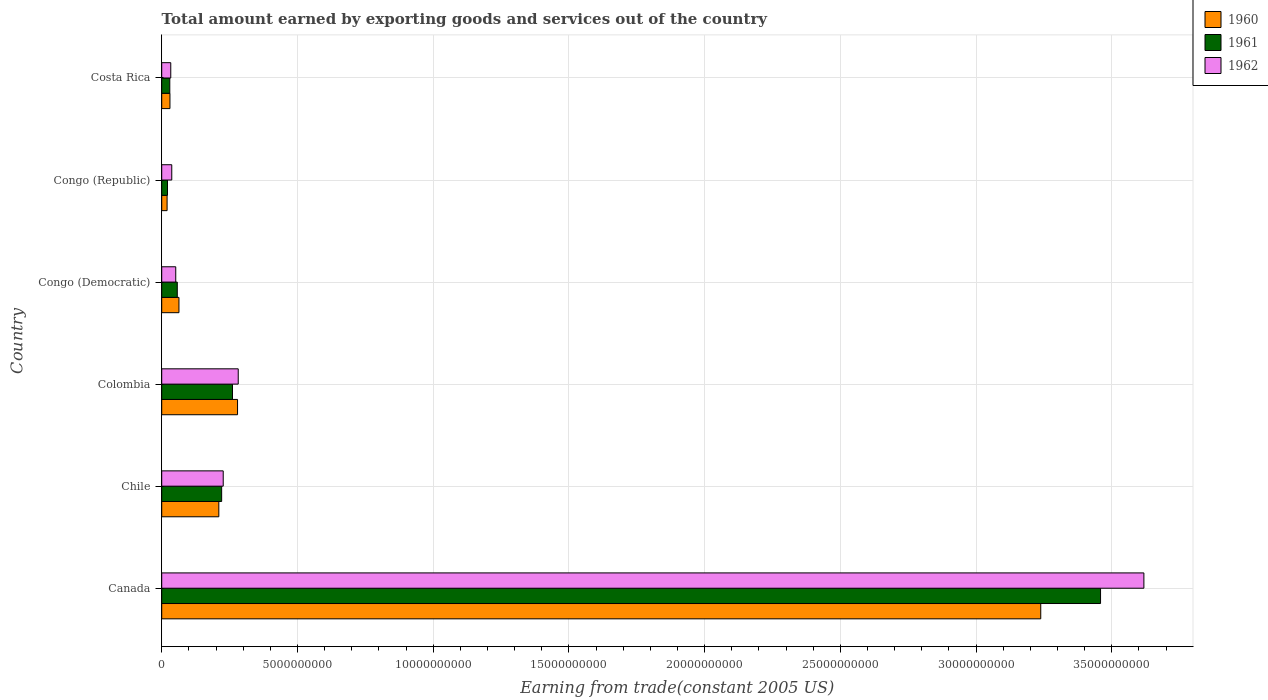How many groups of bars are there?
Make the answer very short. 6. How many bars are there on the 4th tick from the top?
Your answer should be very brief. 3. How many bars are there on the 6th tick from the bottom?
Keep it short and to the point. 3. In how many cases, is the number of bars for a given country not equal to the number of legend labels?
Your answer should be very brief. 0. What is the total amount earned by exporting goods and services in 1960 in Chile?
Give a very brief answer. 2.10e+09. Across all countries, what is the maximum total amount earned by exporting goods and services in 1962?
Make the answer very short. 3.62e+1. Across all countries, what is the minimum total amount earned by exporting goods and services in 1960?
Provide a short and direct response. 1.98e+08. In which country was the total amount earned by exporting goods and services in 1961 minimum?
Provide a succinct answer. Congo (Republic). What is the total total amount earned by exporting goods and services in 1961 in the graph?
Make the answer very short. 4.05e+1. What is the difference between the total amount earned by exporting goods and services in 1960 in Canada and that in Chile?
Provide a short and direct response. 3.03e+1. What is the difference between the total amount earned by exporting goods and services in 1960 in Canada and the total amount earned by exporting goods and services in 1962 in Costa Rica?
Provide a short and direct response. 3.21e+1. What is the average total amount earned by exporting goods and services in 1962 per country?
Give a very brief answer. 7.08e+09. What is the difference between the total amount earned by exporting goods and services in 1960 and total amount earned by exporting goods and services in 1962 in Costa Rica?
Your answer should be very brief. -3.00e+07. In how many countries, is the total amount earned by exporting goods and services in 1960 greater than 35000000000 US$?
Offer a terse response. 0. What is the ratio of the total amount earned by exporting goods and services in 1960 in Colombia to that in Costa Rica?
Offer a very short reply. 9.21. Is the difference between the total amount earned by exporting goods and services in 1960 in Chile and Congo (Republic) greater than the difference between the total amount earned by exporting goods and services in 1962 in Chile and Congo (Republic)?
Your answer should be very brief. Yes. What is the difference between the highest and the second highest total amount earned by exporting goods and services in 1960?
Keep it short and to the point. 2.96e+1. What is the difference between the highest and the lowest total amount earned by exporting goods and services in 1960?
Make the answer very short. 3.22e+1. What does the 3rd bar from the bottom in Costa Rica represents?
Provide a succinct answer. 1962. How many bars are there?
Provide a succinct answer. 18. What is the difference between two consecutive major ticks on the X-axis?
Make the answer very short. 5.00e+09. Are the values on the major ticks of X-axis written in scientific E-notation?
Give a very brief answer. No. Does the graph contain any zero values?
Your answer should be compact. No. How many legend labels are there?
Your answer should be very brief. 3. How are the legend labels stacked?
Your answer should be very brief. Vertical. What is the title of the graph?
Offer a terse response. Total amount earned by exporting goods and services out of the country. What is the label or title of the X-axis?
Give a very brief answer. Earning from trade(constant 2005 US). What is the Earning from trade(constant 2005 US) in 1960 in Canada?
Offer a terse response. 3.24e+1. What is the Earning from trade(constant 2005 US) in 1961 in Canada?
Keep it short and to the point. 3.46e+1. What is the Earning from trade(constant 2005 US) of 1962 in Canada?
Provide a short and direct response. 3.62e+1. What is the Earning from trade(constant 2005 US) of 1960 in Chile?
Make the answer very short. 2.10e+09. What is the Earning from trade(constant 2005 US) of 1961 in Chile?
Offer a very short reply. 2.21e+09. What is the Earning from trade(constant 2005 US) of 1962 in Chile?
Ensure brevity in your answer.  2.27e+09. What is the Earning from trade(constant 2005 US) of 1960 in Colombia?
Offer a terse response. 2.79e+09. What is the Earning from trade(constant 2005 US) of 1961 in Colombia?
Make the answer very short. 2.61e+09. What is the Earning from trade(constant 2005 US) of 1962 in Colombia?
Your answer should be compact. 2.82e+09. What is the Earning from trade(constant 2005 US) in 1960 in Congo (Democratic)?
Your answer should be compact. 6.35e+08. What is the Earning from trade(constant 2005 US) in 1961 in Congo (Democratic)?
Give a very brief answer. 5.73e+08. What is the Earning from trade(constant 2005 US) in 1962 in Congo (Democratic)?
Your answer should be very brief. 5.17e+08. What is the Earning from trade(constant 2005 US) in 1960 in Congo (Republic)?
Keep it short and to the point. 1.98e+08. What is the Earning from trade(constant 2005 US) of 1961 in Congo (Republic)?
Make the answer very short. 2.13e+08. What is the Earning from trade(constant 2005 US) of 1962 in Congo (Republic)?
Offer a very short reply. 3.70e+08. What is the Earning from trade(constant 2005 US) in 1960 in Costa Rica?
Give a very brief answer. 3.03e+08. What is the Earning from trade(constant 2005 US) in 1961 in Costa Rica?
Offer a terse response. 2.98e+08. What is the Earning from trade(constant 2005 US) in 1962 in Costa Rica?
Provide a succinct answer. 3.33e+08. Across all countries, what is the maximum Earning from trade(constant 2005 US) in 1960?
Give a very brief answer. 3.24e+1. Across all countries, what is the maximum Earning from trade(constant 2005 US) of 1961?
Offer a terse response. 3.46e+1. Across all countries, what is the maximum Earning from trade(constant 2005 US) of 1962?
Ensure brevity in your answer.  3.62e+1. Across all countries, what is the minimum Earning from trade(constant 2005 US) of 1960?
Offer a very short reply. 1.98e+08. Across all countries, what is the minimum Earning from trade(constant 2005 US) in 1961?
Your answer should be very brief. 2.13e+08. Across all countries, what is the minimum Earning from trade(constant 2005 US) of 1962?
Offer a very short reply. 3.33e+08. What is the total Earning from trade(constant 2005 US) of 1960 in the graph?
Ensure brevity in your answer.  3.84e+1. What is the total Earning from trade(constant 2005 US) of 1961 in the graph?
Ensure brevity in your answer.  4.05e+1. What is the total Earning from trade(constant 2005 US) in 1962 in the graph?
Make the answer very short. 4.25e+1. What is the difference between the Earning from trade(constant 2005 US) of 1960 in Canada and that in Chile?
Offer a terse response. 3.03e+1. What is the difference between the Earning from trade(constant 2005 US) in 1961 in Canada and that in Chile?
Provide a short and direct response. 3.24e+1. What is the difference between the Earning from trade(constant 2005 US) of 1962 in Canada and that in Chile?
Your response must be concise. 3.39e+1. What is the difference between the Earning from trade(constant 2005 US) in 1960 in Canada and that in Colombia?
Your answer should be very brief. 2.96e+1. What is the difference between the Earning from trade(constant 2005 US) of 1961 in Canada and that in Colombia?
Provide a short and direct response. 3.20e+1. What is the difference between the Earning from trade(constant 2005 US) of 1962 in Canada and that in Colombia?
Your answer should be very brief. 3.34e+1. What is the difference between the Earning from trade(constant 2005 US) of 1960 in Canada and that in Congo (Democratic)?
Your answer should be compact. 3.17e+1. What is the difference between the Earning from trade(constant 2005 US) in 1961 in Canada and that in Congo (Democratic)?
Provide a succinct answer. 3.40e+1. What is the difference between the Earning from trade(constant 2005 US) in 1962 in Canada and that in Congo (Democratic)?
Your response must be concise. 3.57e+1. What is the difference between the Earning from trade(constant 2005 US) of 1960 in Canada and that in Congo (Republic)?
Provide a succinct answer. 3.22e+1. What is the difference between the Earning from trade(constant 2005 US) in 1961 in Canada and that in Congo (Republic)?
Keep it short and to the point. 3.44e+1. What is the difference between the Earning from trade(constant 2005 US) in 1962 in Canada and that in Congo (Republic)?
Offer a very short reply. 3.58e+1. What is the difference between the Earning from trade(constant 2005 US) in 1960 in Canada and that in Costa Rica?
Your answer should be very brief. 3.21e+1. What is the difference between the Earning from trade(constant 2005 US) of 1961 in Canada and that in Costa Rica?
Ensure brevity in your answer.  3.43e+1. What is the difference between the Earning from trade(constant 2005 US) of 1962 in Canada and that in Costa Rica?
Ensure brevity in your answer.  3.58e+1. What is the difference between the Earning from trade(constant 2005 US) of 1960 in Chile and that in Colombia?
Your response must be concise. -6.89e+08. What is the difference between the Earning from trade(constant 2005 US) of 1961 in Chile and that in Colombia?
Offer a terse response. -3.99e+08. What is the difference between the Earning from trade(constant 2005 US) in 1962 in Chile and that in Colombia?
Ensure brevity in your answer.  -5.53e+08. What is the difference between the Earning from trade(constant 2005 US) of 1960 in Chile and that in Congo (Democratic)?
Provide a succinct answer. 1.47e+09. What is the difference between the Earning from trade(constant 2005 US) of 1961 in Chile and that in Congo (Democratic)?
Your answer should be very brief. 1.64e+09. What is the difference between the Earning from trade(constant 2005 US) in 1962 in Chile and that in Congo (Democratic)?
Your response must be concise. 1.75e+09. What is the difference between the Earning from trade(constant 2005 US) in 1960 in Chile and that in Congo (Republic)?
Your response must be concise. 1.91e+09. What is the difference between the Earning from trade(constant 2005 US) of 1961 in Chile and that in Congo (Republic)?
Your response must be concise. 2.00e+09. What is the difference between the Earning from trade(constant 2005 US) of 1962 in Chile and that in Congo (Republic)?
Provide a succinct answer. 1.90e+09. What is the difference between the Earning from trade(constant 2005 US) in 1960 in Chile and that in Costa Rica?
Keep it short and to the point. 1.80e+09. What is the difference between the Earning from trade(constant 2005 US) in 1961 in Chile and that in Costa Rica?
Offer a terse response. 1.91e+09. What is the difference between the Earning from trade(constant 2005 US) in 1962 in Chile and that in Costa Rica?
Offer a very short reply. 1.93e+09. What is the difference between the Earning from trade(constant 2005 US) of 1960 in Colombia and that in Congo (Democratic)?
Make the answer very short. 2.16e+09. What is the difference between the Earning from trade(constant 2005 US) in 1961 in Colombia and that in Congo (Democratic)?
Make the answer very short. 2.03e+09. What is the difference between the Earning from trade(constant 2005 US) of 1962 in Colombia and that in Congo (Democratic)?
Your response must be concise. 2.30e+09. What is the difference between the Earning from trade(constant 2005 US) in 1960 in Colombia and that in Congo (Republic)?
Make the answer very short. 2.60e+09. What is the difference between the Earning from trade(constant 2005 US) of 1961 in Colombia and that in Congo (Republic)?
Your answer should be compact. 2.39e+09. What is the difference between the Earning from trade(constant 2005 US) of 1962 in Colombia and that in Congo (Republic)?
Your response must be concise. 2.45e+09. What is the difference between the Earning from trade(constant 2005 US) in 1960 in Colombia and that in Costa Rica?
Offer a terse response. 2.49e+09. What is the difference between the Earning from trade(constant 2005 US) of 1961 in Colombia and that in Costa Rica?
Give a very brief answer. 2.31e+09. What is the difference between the Earning from trade(constant 2005 US) of 1962 in Colombia and that in Costa Rica?
Offer a very short reply. 2.49e+09. What is the difference between the Earning from trade(constant 2005 US) of 1960 in Congo (Democratic) and that in Congo (Republic)?
Give a very brief answer. 4.37e+08. What is the difference between the Earning from trade(constant 2005 US) in 1961 in Congo (Democratic) and that in Congo (Republic)?
Offer a very short reply. 3.60e+08. What is the difference between the Earning from trade(constant 2005 US) in 1962 in Congo (Democratic) and that in Congo (Republic)?
Give a very brief answer. 1.47e+08. What is the difference between the Earning from trade(constant 2005 US) in 1960 in Congo (Democratic) and that in Costa Rica?
Provide a succinct answer. 3.32e+08. What is the difference between the Earning from trade(constant 2005 US) in 1961 in Congo (Democratic) and that in Costa Rica?
Provide a succinct answer. 2.76e+08. What is the difference between the Earning from trade(constant 2005 US) in 1962 in Congo (Democratic) and that in Costa Rica?
Offer a very short reply. 1.84e+08. What is the difference between the Earning from trade(constant 2005 US) of 1960 in Congo (Republic) and that in Costa Rica?
Your answer should be compact. -1.05e+08. What is the difference between the Earning from trade(constant 2005 US) in 1961 in Congo (Republic) and that in Costa Rica?
Your response must be concise. -8.47e+07. What is the difference between the Earning from trade(constant 2005 US) of 1962 in Congo (Republic) and that in Costa Rica?
Your response must be concise. 3.67e+07. What is the difference between the Earning from trade(constant 2005 US) in 1960 in Canada and the Earning from trade(constant 2005 US) in 1961 in Chile?
Give a very brief answer. 3.02e+1. What is the difference between the Earning from trade(constant 2005 US) of 1960 in Canada and the Earning from trade(constant 2005 US) of 1962 in Chile?
Provide a succinct answer. 3.01e+1. What is the difference between the Earning from trade(constant 2005 US) in 1961 in Canada and the Earning from trade(constant 2005 US) in 1962 in Chile?
Offer a very short reply. 3.23e+1. What is the difference between the Earning from trade(constant 2005 US) of 1960 in Canada and the Earning from trade(constant 2005 US) of 1961 in Colombia?
Your response must be concise. 2.98e+1. What is the difference between the Earning from trade(constant 2005 US) in 1960 in Canada and the Earning from trade(constant 2005 US) in 1962 in Colombia?
Your answer should be compact. 2.96e+1. What is the difference between the Earning from trade(constant 2005 US) of 1961 in Canada and the Earning from trade(constant 2005 US) of 1962 in Colombia?
Offer a very short reply. 3.18e+1. What is the difference between the Earning from trade(constant 2005 US) of 1960 in Canada and the Earning from trade(constant 2005 US) of 1961 in Congo (Democratic)?
Offer a very short reply. 3.18e+1. What is the difference between the Earning from trade(constant 2005 US) of 1960 in Canada and the Earning from trade(constant 2005 US) of 1962 in Congo (Democratic)?
Provide a succinct answer. 3.19e+1. What is the difference between the Earning from trade(constant 2005 US) of 1961 in Canada and the Earning from trade(constant 2005 US) of 1962 in Congo (Democratic)?
Your response must be concise. 3.41e+1. What is the difference between the Earning from trade(constant 2005 US) in 1960 in Canada and the Earning from trade(constant 2005 US) in 1961 in Congo (Republic)?
Your response must be concise. 3.22e+1. What is the difference between the Earning from trade(constant 2005 US) of 1960 in Canada and the Earning from trade(constant 2005 US) of 1962 in Congo (Republic)?
Make the answer very short. 3.20e+1. What is the difference between the Earning from trade(constant 2005 US) in 1961 in Canada and the Earning from trade(constant 2005 US) in 1962 in Congo (Republic)?
Give a very brief answer. 3.42e+1. What is the difference between the Earning from trade(constant 2005 US) in 1960 in Canada and the Earning from trade(constant 2005 US) in 1961 in Costa Rica?
Ensure brevity in your answer.  3.21e+1. What is the difference between the Earning from trade(constant 2005 US) of 1960 in Canada and the Earning from trade(constant 2005 US) of 1962 in Costa Rica?
Offer a very short reply. 3.21e+1. What is the difference between the Earning from trade(constant 2005 US) in 1961 in Canada and the Earning from trade(constant 2005 US) in 1962 in Costa Rica?
Your response must be concise. 3.43e+1. What is the difference between the Earning from trade(constant 2005 US) in 1960 in Chile and the Earning from trade(constant 2005 US) in 1961 in Colombia?
Offer a very short reply. -5.03e+08. What is the difference between the Earning from trade(constant 2005 US) of 1960 in Chile and the Earning from trade(constant 2005 US) of 1962 in Colombia?
Your answer should be compact. -7.14e+08. What is the difference between the Earning from trade(constant 2005 US) in 1961 in Chile and the Earning from trade(constant 2005 US) in 1962 in Colombia?
Provide a short and direct response. -6.10e+08. What is the difference between the Earning from trade(constant 2005 US) of 1960 in Chile and the Earning from trade(constant 2005 US) of 1961 in Congo (Democratic)?
Your answer should be very brief. 1.53e+09. What is the difference between the Earning from trade(constant 2005 US) in 1960 in Chile and the Earning from trade(constant 2005 US) in 1962 in Congo (Democratic)?
Give a very brief answer. 1.59e+09. What is the difference between the Earning from trade(constant 2005 US) of 1961 in Chile and the Earning from trade(constant 2005 US) of 1962 in Congo (Democratic)?
Ensure brevity in your answer.  1.69e+09. What is the difference between the Earning from trade(constant 2005 US) of 1960 in Chile and the Earning from trade(constant 2005 US) of 1961 in Congo (Republic)?
Your answer should be compact. 1.89e+09. What is the difference between the Earning from trade(constant 2005 US) of 1960 in Chile and the Earning from trade(constant 2005 US) of 1962 in Congo (Republic)?
Give a very brief answer. 1.73e+09. What is the difference between the Earning from trade(constant 2005 US) of 1961 in Chile and the Earning from trade(constant 2005 US) of 1962 in Congo (Republic)?
Offer a terse response. 1.84e+09. What is the difference between the Earning from trade(constant 2005 US) of 1960 in Chile and the Earning from trade(constant 2005 US) of 1961 in Costa Rica?
Provide a short and direct response. 1.81e+09. What is the difference between the Earning from trade(constant 2005 US) of 1960 in Chile and the Earning from trade(constant 2005 US) of 1962 in Costa Rica?
Your answer should be very brief. 1.77e+09. What is the difference between the Earning from trade(constant 2005 US) of 1961 in Chile and the Earning from trade(constant 2005 US) of 1962 in Costa Rica?
Make the answer very short. 1.87e+09. What is the difference between the Earning from trade(constant 2005 US) in 1960 in Colombia and the Earning from trade(constant 2005 US) in 1961 in Congo (Democratic)?
Ensure brevity in your answer.  2.22e+09. What is the difference between the Earning from trade(constant 2005 US) of 1960 in Colombia and the Earning from trade(constant 2005 US) of 1962 in Congo (Democratic)?
Keep it short and to the point. 2.28e+09. What is the difference between the Earning from trade(constant 2005 US) in 1961 in Colombia and the Earning from trade(constant 2005 US) in 1962 in Congo (Democratic)?
Provide a succinct answer. 2.09e+09. What is the difference between the Earning from trade(constant 2005 US) in 1960 in Colombia and the Earning from trade(constant 2005 US) in 1961 in Congo (Republic)?
Provide a short and direct response. 2.58e+09. What is the difference between the Earning from trade(constant 2005 US) of 1960 in Colombia and the Earning from trade(constant 2005 US) of 1962 in Congo (Republic)?
Provide a succinct answer. 2.42e+09. What is the difference between the Earning from trade(constant 2005 US) of 1961 in Colombia and the Earning from trade(constant 2005 US) of 1962 in Congo (Republic)?
Offer a terse response. 2.24e+09. What is the difference between the Earning from trade(constant 2005 US) of 1960 in Colombia and the Earning from trade(constant 2005 US) of 1961 in Costa Rica?
Your answer should be compact. 2.50e+09. What is the difference between the Earning from trade(constant 2005 US) in 1960 in Colombia and the Earning from trade(constant 2005 US) in 1962 in Costa Rica?
Your response must be concise. 2.46e+09. What is the difference between the Earning from trade(constant 2005 US) of 1961 in Colombia and the Earning from trade(constant 2005 US) of 1962 in Costa Rica?
Provide a succinct answer. 2.27e+09. What is the difference between the Earning from trade(constant 2005 US) in 1960 in Congo (Democratic) and the Earning from trade(constant 2005 US) in 1961 in Congo (Republic)?
Your answer should be very brief. 4.22e+08. What is the difference between the Earning from trade(constant 2005 US) in 1960 in Congo (Democratic) and the Earning from trade(constant 2005 US) in 1962 in Congo (Republic)?
Keep it short and to the point. 2.65e+08. What is the difference between the Earning from trade(constant 2005 US) of 1961 in Congo (Democratic) and the Earning from trade(constant 2005 US) of 1962 in Congo (Republic)?
Keep it short and to the point. 2.03e+08. What is the difference between the Earning from trade(constant 2005 US) of 1960 in Congo (Democratic) and the Earning from trade(constant 2005 US) of 1961 in Costa Rica?
Give a very brief answer. 3.38e+08. What is the difference between the Earning from trade(constant 2005 US) in 1960 in Congo (Democratic) and the Earning from trade(constant 2005 US) in 1962 in Costa Rica?
Ensure brevity in your answer.  3.02e+08. What is the difference between the Earning from trade(constant 2005 US) of 1961 in Congo (Democratic) and the Earning from trade(constant 2005 US) of 1962 in Costa Rica?
Provide a succinct answer. 2.40e+08. What is the difference between the Earning from trade(constant 2005 US) in 1960 in Congo (Republic) and the Earning from trade(constant 2005 US) in 1961 in Costa Rica?
Your answer should be very brief. -9.96e+07. What is the difference between the Earning from trade(constant 2005 US) of 1960 in Congo (Republic) and the Earning from trade(constant 2005 US) of 1962 in Costa Rica?
Your answer should be very brief. -1.35e+08. What is the difference between the Earning from trade(constant 2005 US) in 1961 in Congo (Republic) and the Earning from trade(constant 2005 US) in 1962 in Costa Rica?
Make the answer very short. -1.20e+08. What is the average Earning from trade(constant 2005 US) of 1960 per country?
Provide a short and direct response. 6.40e+09. What is the average Earning from trade(constant 2005 US) in 1961 per country?
Provide a succinct answer. 6.75e+09. What is the average Earning from trade(constant 2005 US) in 1962 per country?
Keep it short and to the point. 7.08e+09. What is the difference between the Earning from trade(constant 2005 US) in 1960 and Earning from trade(constant 2005 US) in 1961 in Canada?
Make the answer very short. -2.20e+09. What is the difference between the Earning from trade(constant 2005 US) of 1960 and Earning from trade(constant 2005 US) of 1962 in Canada?
Give a very brief answer. -3.80e+09. What is the difference between the Earning from trade(constant 2005 US) of 1961 and Earning from trade(constant 2005 US) of 1962 in Canada?
Keep it short and to the point. -1.60e+09. What is the difference between the Earning from trade(constant 2005 US) in 1960 and Earning from trade(constant 2005 US) in 1961 in Chile?
Your answer should be very brief. -1.04e+08. What is the difference between the Earning from trade(constant 2005 US) in 1960 and Earning from trade(constant 2005 US) in 1962 in Chile?
Your answer should be compact. -1.62e+08. What is the difference between the Earning from trade(constant 2005 US) in 1961 and Earning from trade(constant 2005 US) in 1962 in Chile?
Your answer should be very brief. -5.76e+07. What is the difference between the Earning from trade(constant 2005 US) of 1960 and Earning from trade(constant 2005 US) of 1961 in Colombia?
Keep it short and to the point. 1.86e+08. What is the difference between the Earning from trade(constant 2005 US) of 1960 and Earning from trade(constant 2005 US) of 1962 in Colombia?
Ensure brevity in your answer.  -2.49e+07. What is the difference between the Earning from trade(constant 2005 US) in 1961 and Earning from trade(constant 2005 US) in 1962 in Colombia?
Provide a succinct answer. -2.11e+08. What is the difference between the Earning from trade(constant 2005 US) in 1960 and Earning from trade(constant 2005 US) in 1961 in Congo (Democratic)?
Provide a succinct answer. 6.20e+07. What is the difference between the Earning from trade(constant 2005 US) in 1960 and Earning from trade(constant 2005 US) in 1962 in Congo (Democratic)?
Make the answer very short. 1.18e+08. What is the difference between the Earning from trade(constant 2005 US) in 1961 and Earning from trade(constant 2005 US) in 1962 in Congo (Democratic)?
Your answer should be very brief. 5.64e+07. What is the difference between the Earning from trade(constant 2005 US) in 1960 and Earning from trade(constant 2005 US) in 1961 in Congo (Republic)?
Make the answer very short. -1.49e+07. What is the difference between the Earning from trade(constant 2005 US) of 1960 and Earning from trade(constant 2005 US) of 1962 in Congo (Republic)?
Give a very brief answer. -1.72e+08. What is the difference between the Earning from trade(constant 2005 US) in 1961 and Earning from trade(constant 2005 US) in 1962 in Congo (Republic)?
Make the answer very short. -1.57e+08. What is the difference between the Earning from trade(constant 2005 US) of 1960 and Earning from trade(constant 2005 US) of 1961 in Costa Rica?
Your response must be concise. 5.57e+06. What is the difference between the Earning from trade(constant 2005 US) of 1960 and Earning from trade(constant 2005 US) of 1962 in Costa Rica?
Your answer should be compact. -3.00e+07. What is the difference between the Earning from trade(constant 2005 US) of 1961 and Earning from trade(constant 2005 US) of 1962 in Costa Rica?
Your answer should be compact. -3.56e+07. What is the ratio of the Earning from trade(constant 2005 US) of 1960 in Canada to that in Chile?
Your response must be concise. 15.39. What is the ratio of the Earning from trade(constant 2005 US) in 1961 in Canada to that in Chile?
Provide a short and direct response. 15.66. What is the ratio of the Earning from trade(constant 2005 US) in 1962 in Canada to that in Chile?
Ensure brevity in your answer.  15.97. What is the ratio of the Earning from trade(constant 2005 US) of 1960 in Canada to that in Colombia?
Provide a succinct answer. 11.59. What is the ratio of the Earning from trade(constant 2005 US) in 1961 in Canada to that in Colombia?
Ensure brevity in your answer.  13.26. What is the ratio of the Earning from trade(constant 2005 US) of 1962 in Canada to that in Colombia?
Offer a very short reply. 12.84. What is the ratio of the Earning from trade(constant 2005 US) of 1960 in Canada to that in Congo (Democratic)?
Keep it short and to the point. 50.97. What is the ratio of the Earning from trade(constant 2005 US) in 1961 in Canada to that in Congo (Democratic)?
Keep it short and to the point. 60.32. What is the ratio of the Earning from trade(constant 2005 US) of 1962 in Canada to that in Congo (Democratic)?
Provide a succinct answer. 69.98. What is the ratio of the Earning from trade(constant 2005 US) of 1960 in Canada to that in Congo (Republic)?
Your response must be concise. 163.31. What is the ratio of the Earning from trade(constant 2005 US) in 1961 in Canada to that in Congo (Republic)?
Offer a terse response. 162.25. What is the ratio of the Earning from trade(constant 2005 US) in 1962 in Canada to that in Congo (Republic)?
Ensure brevity in your answer.  97.75. What is the ratio of the Earning from trade(constant 2005 US) of 1960 in Canada to that in Costa Rica?
Keep it short and to the point. 106.72. What is the ratio of the Earning from trade(constant 2005 US) of 1961 in Canada to that in Costa Rica?
Offer a very short reply. 116.1. What is the ratio of the Earning from trade(constant 2005 US) of 1962 in Canada to that in Costa Rica?
Offer a very short reply. 108.5. What is the ratio of the Earning from trade(constant 2005 US) in 1960 in Chile to that in Colombia?
Your answer should be very brief. 0.75. What is the ratio of the Earning from trade(constant 2005 US) in 1961 in Chile to that in Colombia?
Offer a very short reply. 0.85. What is the ratio of the Earning from trade(constant 2005 US) of 1962 in Chile to that in Colombia?
Keep it short and to the point. 0.8. What is the ratio of the Earning from trade(constant 2005 US) in 1960 in Chile to that in Congo (Democratic)?
Make the answer very short. 3.31. What is the ratio of the Earning from trade(constant 2005 US) of 1961 in Chile to that in Congo (Democratic)?
Offer a very short reply. 3.85. What is the ratio of the Earning from trade(constant 2005 US) in 1962 in Chile to that in Congo (Democratic)?
Provide a short and direct response. 4.38. What is the ratio of the Earning from trade(constant 2005 US) of 1960 in Chile to that in Congo (Republic)?
Keep it short and to the point. 10.61. What is the ratio of the Earning from trade(constant 2005 US) in 1961 in Chile to that in Congo (Republic)?
Ensure brevity in your answer.  10.36. What is the ratio of the Earning from trade(constant 2005 US) in 1962 in Chile to that in Congo (Republic)?
Make the answer very short. 6.12. What is the ratio of the Earning from trade(constant 2005 US) of 1960 in Chile to that in Costa Rica?
Your answer should be compact. 6.93. What is the ratio of the Earning from trade(constant 2005 US) of 1961 in Chile to that in Costa Rica?
Offer a terse response. 7.41. What is the ratio of the Earning from trade(constant 2005 US) of 1962 in Chile to that in Costa Rica?
Your answer should be very brief. 6.8. What is the ratio of the Earning from trade(constant 2005 US) of 1960 in Colombia to that in Congo (Democratic)?
Keep it short and to the point. 4.4. What is the ratio of the Earning from trade(constant 2005 US) of 1961 in Colombia to that in Congo (Democratic)?
Make the answer very short. 4.55. What is the ratio of the Earning from trade(constant 2005 US) of 1962 in Colombia to that in Congo (Democratic)?
Offer a terse response. 5.45. What is the ratio of the Earning from trade(constant 2005 US) of 1960 in Colombia to that in Congo (Republic)?
Make the answer very short. 14.09. What is the ratio of the Earning from trade(constant 2005 US) in 1961 in Colombia to that in Congo (Republic)?
Give a very brief answer. 12.23. What is the ratio of the Earning from trade(constant 2005 US) in 1962 in Colombia to that in Congo (Republic)?
Give a very brief answer. 7.62. What is the ratio of the Earning from trade(constant 2005 US) in 1960 in Colombia to that in Costa Rica?
Make the answer very short. 9.21. What is the ratio of the Earning from trade(constant 2005 US) of 1961 in Colombia to that in Costa Rica?
Your response must be concise. 8.75. What is the ratio of the Earning from trade(constant 2005 US) of 1962 in Colombia to that in Costa Rica?
Your answer should be very brief. 8.45. What is the ratio of the Earning from trade(constant 2005 US) in 1960 in Congo (Democratic) to that in Congo (Republic)?
Make the answer very short. 3.2. What is the ratio of the Earning from trade(constant 2005 US) of 1961 in Congo (Democratic) to that in Congo (Republic)?
Make the answer very short. 2.69. What is the ratio of the Earning from trade(constant 2005 US) of 1962 in Congo (Democratic) to that in Congo (Republic)?
Offer a very short reply. 1.4. What is the ratio of the Earning from trade(constant 2005 US) in 1960 in Congo (Democratic) to that in Costa Rica?
Ensure brevity in your answer.  2.09. What is the ratio of the Earning from trade(constant 2005 US) in 1961 in Congo (Democratic) to that in Costa Rica?
Provide a succinct answer. 1.92. What is the ratio of the Earning from trade(constant 2005 US) in 1962 in Congo (Democratic) to that in Costa Rica?
Your response must be concise. 1.55. What is the ratio of the Earning from trade(constant 2005 US) of 1960 in Congo (Republic) to that in Costa Rica?
Give a very brief answer. 0.65. What is the ratio of the Earning from trade(constant 2005 US) of 1961 in Congo (Republic) to that in Costa Rica?
Provide a succinct answer. 0.72. What is the ratio of the Earning from trade(constant 2005 US) in 1962 in Congo (Republic) to that in Costa Rica?
Your answer should be very brief. 1.11. What is the difference between the highest and the second highest Earning from trade(constant 2005 US) of 1960?
Offer a very short reply. 2.96e+1. What is the difference between the highest and the second highest Earning from trade(constant 2005 US) in 1961?
Offer a very short reply. 3.20e+1. What is the difference between the highest and the second highest Earning from trade(constant 2005 US) in 1962?
Provide a succinct answer. 3.34e+1. What is the difference between the highest and the lowest Earning from trade(constant 2005 US) of 1960?
Your answer should be very brief. 3.22e+1. What is the difference between the highest and the lowest Earning from trade(constant 2005 US) in 1961?
Make the answer very short. 3.44e+1. What is the difference between the highest and the lowest Earning from trade(constant 2005 US) of 1962?
Your answer should be compact. 3.58e+1. 